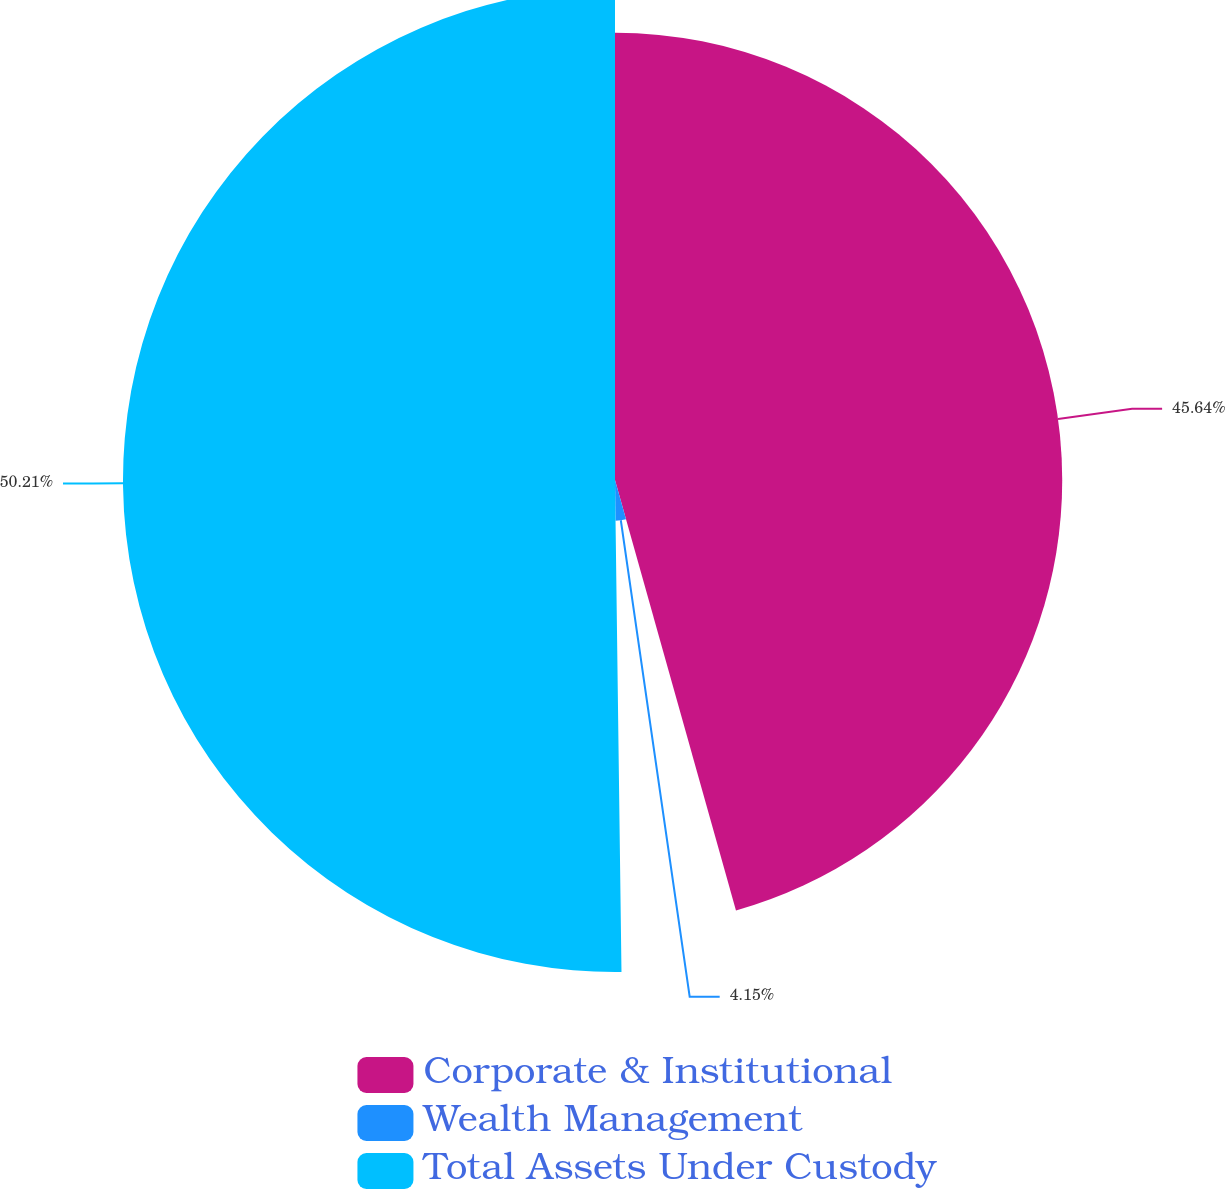Convert chart to OTSL. <chart><loc_0><loc_0><loc_500><loc_500><pie_chart><fcel>Corporate & Institutional<fcel>Wealth Management<fcel>Total Assets Under Custody<nl><fcel>45.64%<fcel>4.15%<fcel>50.21%<nl></chart> 